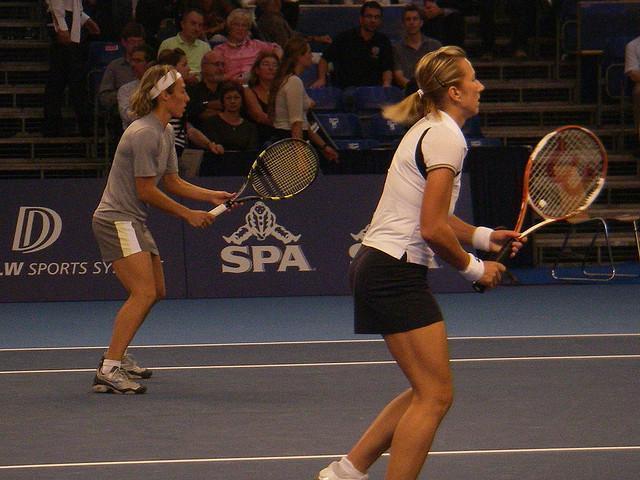How many people are visible?
Give a very brief answer. 8. How many tennis rackets can you see?
Give a very brief answer. 2. How many people are wearing orange glasses?
Give a very brief answer. 0. 